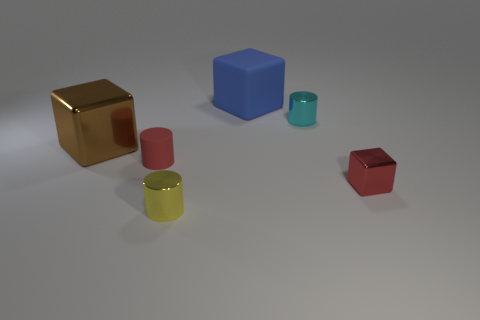Add 4 cyan balls. How many objects exist? 10 Subtract all small metal cylinders. How many cylinders are left? 1 Subtract 1 cubes. How many cubes are left? 2 Add 6 big red cubes. How many big red cubes exist? 6 Subtract 0 cyan blocks. How many objects are left? 6 Subtract all purple metal objects. Subtract all large matte cubes. How many objects are left? 5 Add 2 small objects. How many small objects are left? 6 